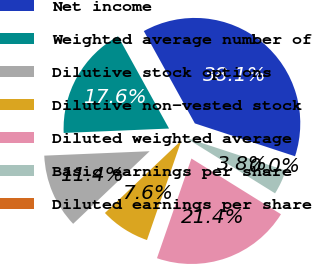<chart> <loc_0><loc_0><loc_500><loc_500><pie_chart><fcel>Net income<fcel>Weighted average number of<fcel>Dilutive stock options<fcel>Dilutive non-vested stock<fcel>Diluted weighted average<fcel>Basic earnings per share<fcel>Diluted earnings per share<nl><fcel>38.08%<fcel>17.63%<fcel>11.42%<fcel>7.62%<fcel>21.44%<fcel>3.81%<fcel>0.0%<nl></chart> 